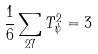<formula> <loc_0><loc_0><loc_500><loc_500>\frac { 1 } { 6 } \sum _ { 2 7 } T ^ { 2 } _ { \psi } = 3</formula> 